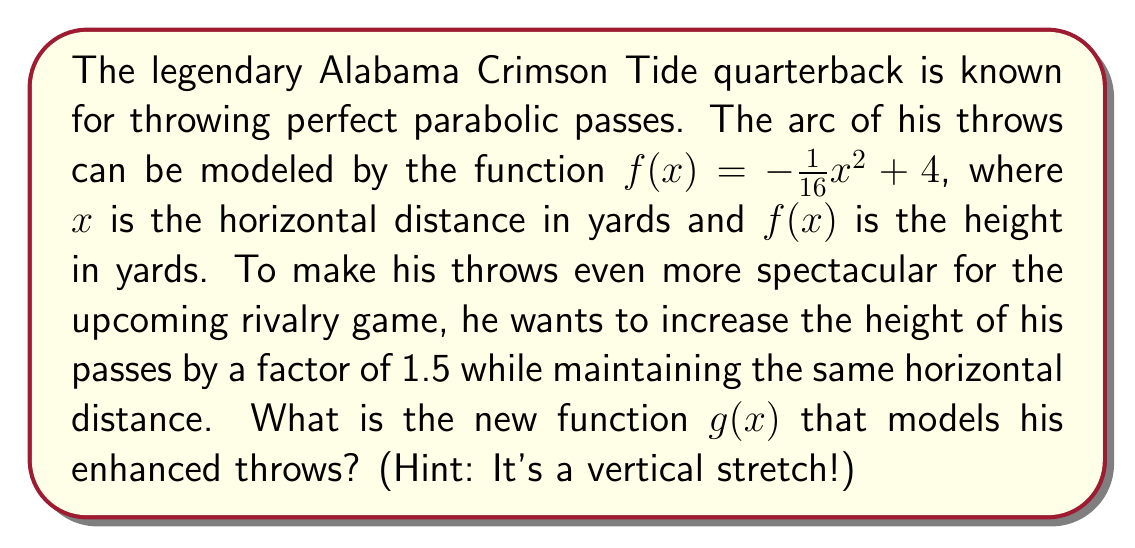Give your solution to this math problem. Let's approach this step-by-step:

1) The original function is $f(x) = -\frac{1}{16}x^2 + 4$

2) We want to stretch this function vertically by a factor of 1.5. In general, to vertically stretch a function by a factor of $k$, we multiply the entire function by $k$:

   $g(x) = k \cdot f(x)$

3) In this case, $k = 1.5$, so:

   $g(x) = 1.5 \cdot f(x)$

4) Substituting the original function:

   $g(x) = 1.5 \cdot (-\frac{1}{16}x^2 + 4)$

5) Distributing the 1.5:

   $g(x) = -1.5 \cdot \frac{1}{16}x^2 + 1.5 \cdot 4$

6) Simplifying:

   $g(x) = -\frac{3}{32}x^2 + 6$

This new function $g(x)$ will have the same x-intercepts as $f(x)$, but its maximum height will be 1.5 times greater.
Answer: $g(x) = -\frac{3}{32}x^2 + 6$ 